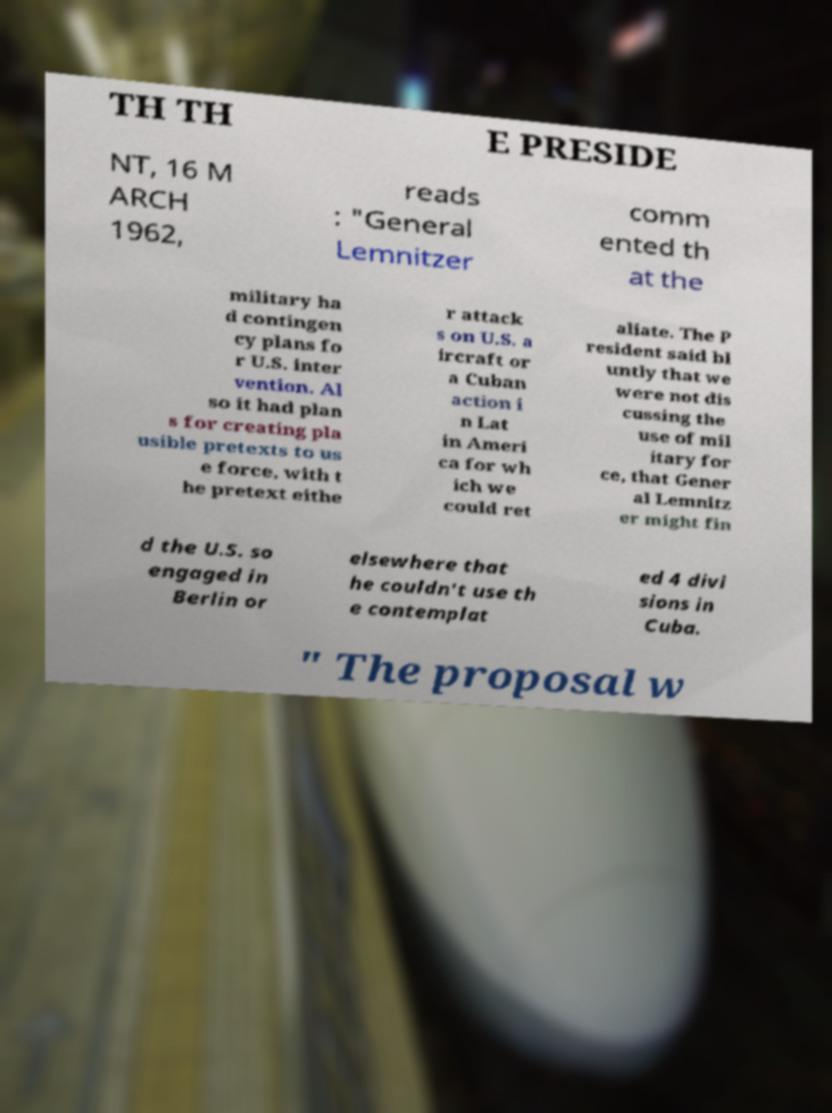What messages or text are displayed in this image? I need them in a readable, typed format. TH TH E PRESIDE NT, 16 M ARCH 1962, reads : "General Lemnitzer comm ented th at the military ha d contingen cy plans fo r U.S. inter vention. Al so it had plan s for creating pla usible pretexts to us e force, with t he pretext eithe r attack s on U.S. a ircraft or a Cuban action i n Lat in Ameri ca for wh ich we could ret aliate. The P resident said bl untly that we were not dis cussing the use of mil itary for ce, that Gener al Lemnitz er might fin d the U.S. so engaged in Berlin or elsewhere that he couldn't use th e contemplat ed 4 divi sions in Cuba. " The proposal w 